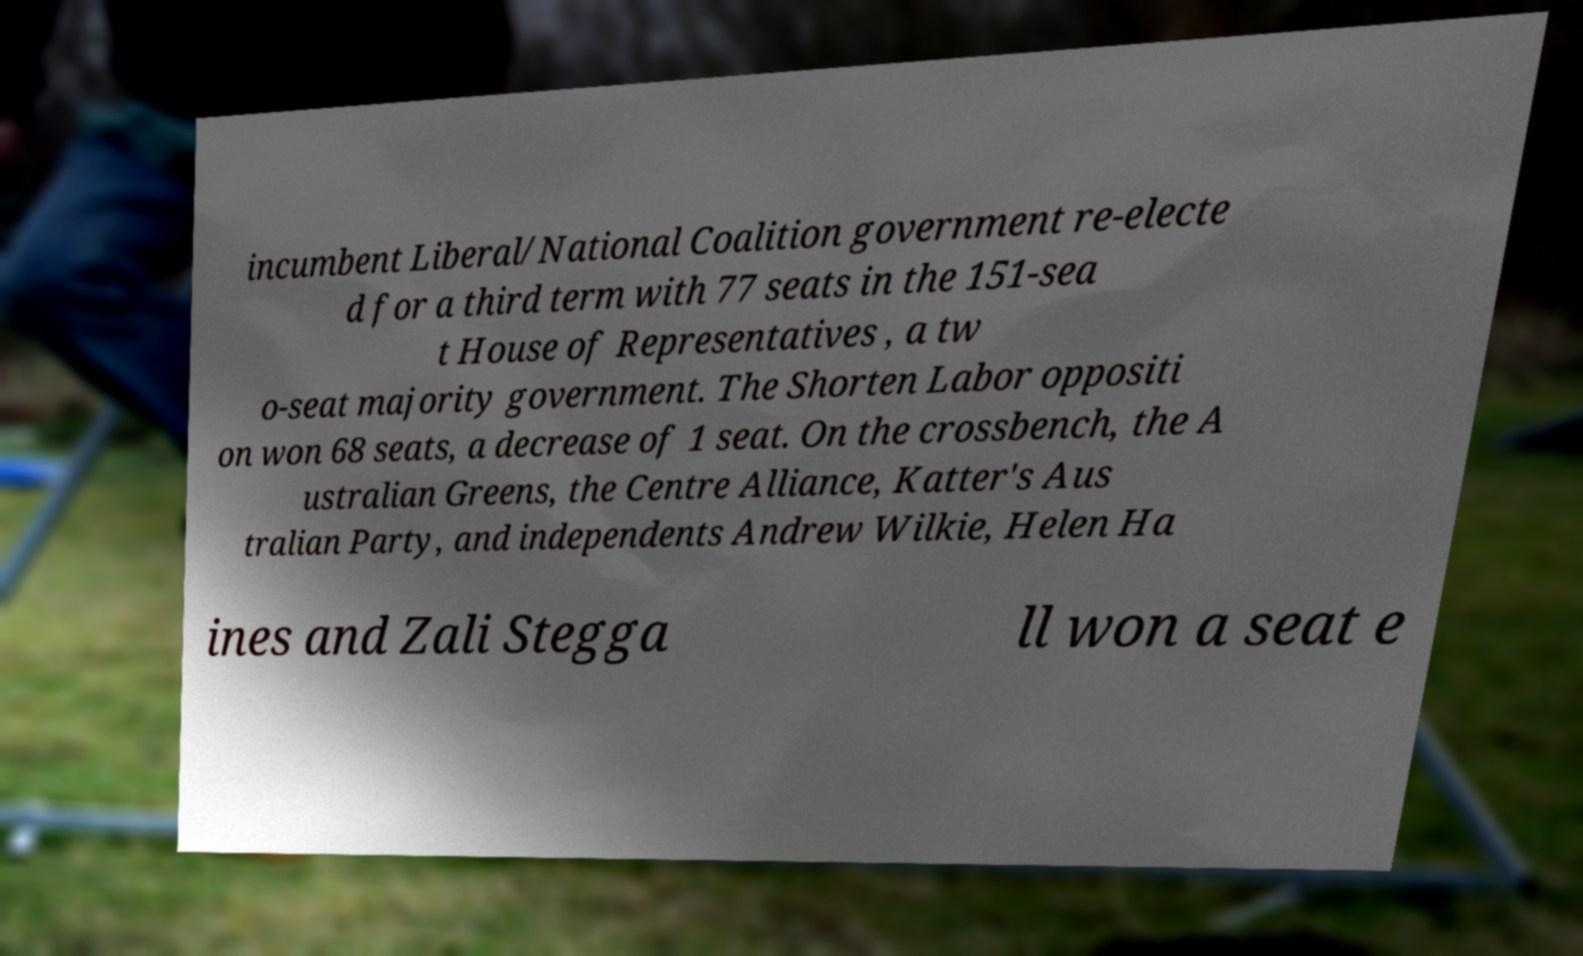What messages or text are displayed in this image? I need them in a readable, typed format. incumbent Liberal/National Coalition government re-electe d for a third term with 77 seats in the 151-sea t House of Representatives , a tw o-seat majority government. The Shorten Labor oppositi on won 68 seats, a decrease of 1 seat. On the crossbench, the A ustralian Greens, the Centre Alliance, Katter's Aus tralian Party, and independents Andrew Wilkie, Helen Ha ines and Zali Stegga ll won a seat e 